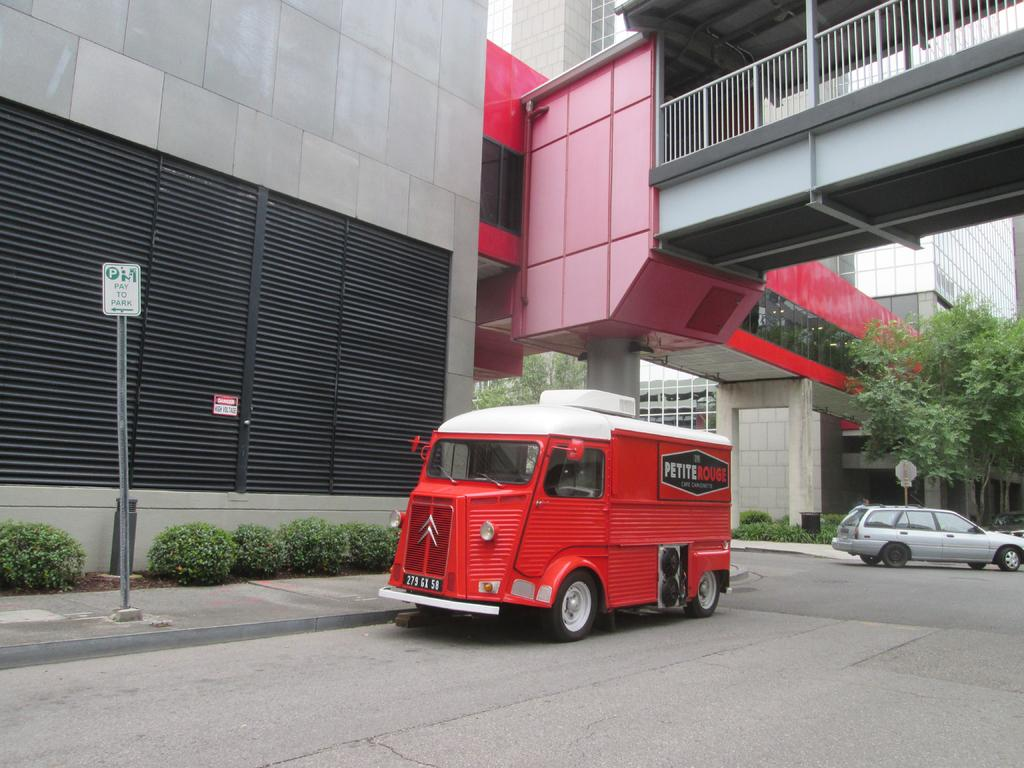What is the main subject in the center of the image? There is a van in the center of the image. What other vehicle can be seen in the image? There is a car on the right side of the image. What type of structures are present in the center of the image? There are buildings in the center of the image. How many rings are visible on the hen in the image? There is no hen or rings present in the image. Is the grass visible in the image? The provided facts do not mention any grass in the image. 